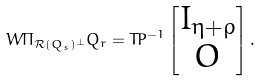Convert formula to latex. <formula><loc_0><loc_0><loc_500><loc_500>W \Pi _ { \mathcal { R } ( Q _ { s } ) ^ { \perp } } Q _ { r } = T P ^ { - 1 } \begin{bmatrix} I _ { \eta + \rho } \\ O \end{bmatrix} .</formula> 